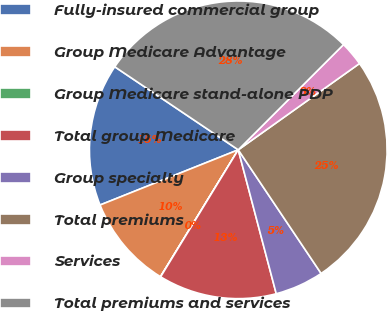Convert chart to OTSL. <chart><loc_0><loc_0><loc_500><loc_500><pie_chart><fcel>Fully-insured commercial group<fcel>Group Medicare Advantage<fcel>Group Medicare stand-alone PDP<fcel>Total group Medicare<fcel>Group specialty<fcel>Total premiums<fcel>Services<fcel>Total premiums and services<nl><fcel>15.47%<fcel>10.2%<fcel>0.02%<fcel>12.84%<fcel>5.29%<fcel>25.45%<fcel>2.65%<fcel>28.08%<nl></chart> 